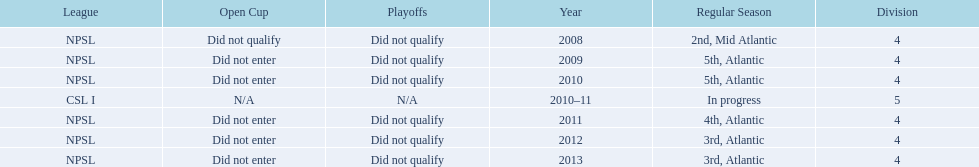What are the leagues? NPSL, NPSL, NPSL, CSL I, NPSL, NPSL, NPSL. Of these, what league is not npsl? CSL I. 